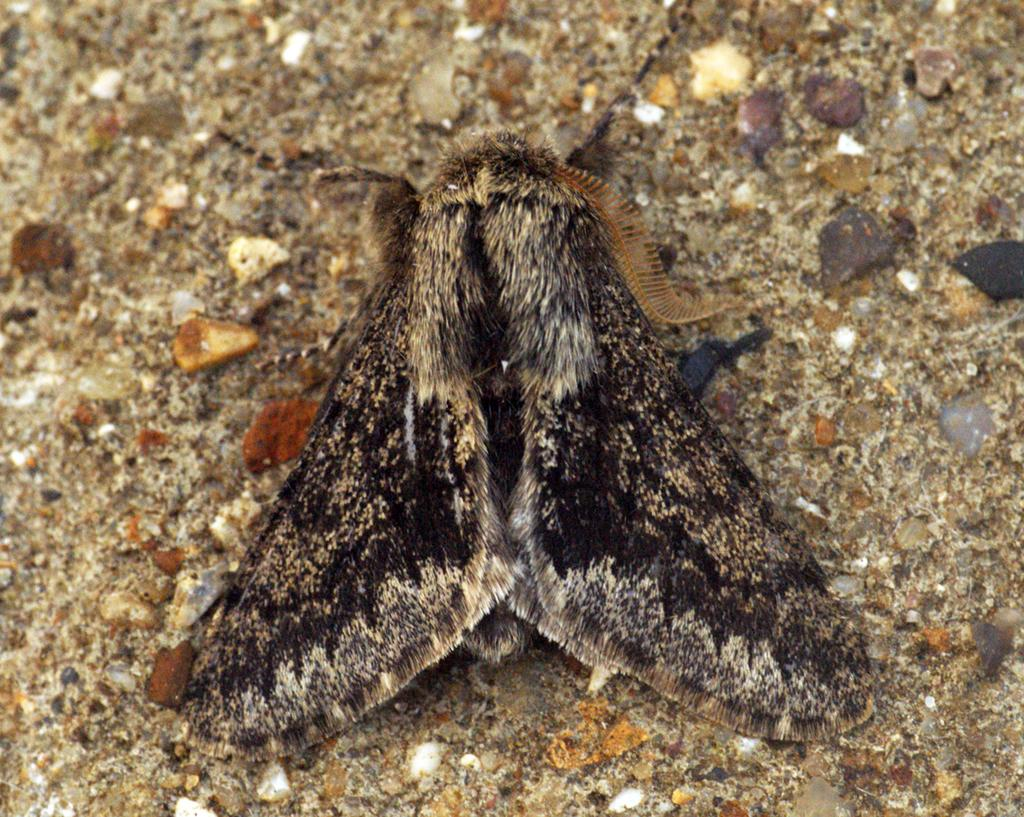What type of creature can be seen on the surface in the image? There is an insect on the surface in the image. What other objects can be seen in the image besides the insect? There are stones visible in the image. What type of flame can be seen burning on the insect in the image? There is no flame present in the image; it features an insect and stones. What type of quill is the insect holding in the image? There is no quill present in the image; it features an insect and stones. 